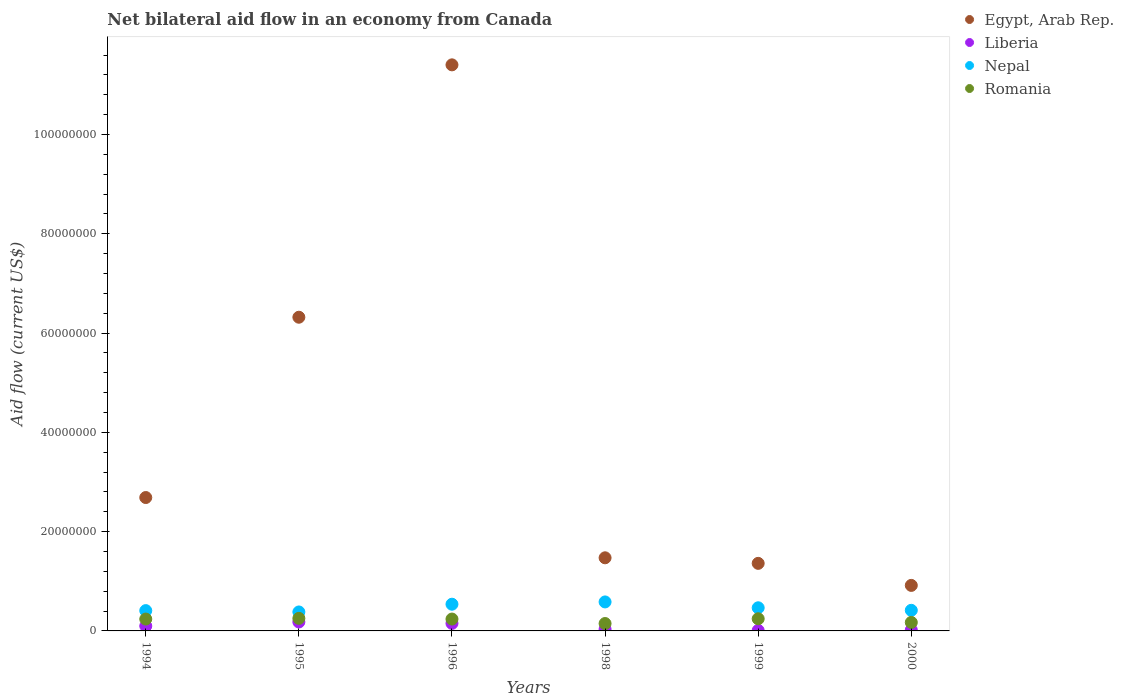How many different coloured dotlines are there?
Give a very brief answer. 4. Is the number of dotlines equal to the number of legend labels?
Your answer should be compact. Yes. What is the net bilateral aid flow in Egypt, Arab Rep. in 1999?
Your answer should be compact. 1.36e+07. Across all years, what is the maximum net bilateral aid flow in Egypt, Arab Rep.?
Your response must be concise. 1.14e+08. Across all years, what is the minimum net bilateral aid flow in Nepal?
Offer a terse response. 3.82e+06. In which year was the net bilateral aid flow in Nepal minimum?
Make the answer very short. 1995. What is the total net bilateral aid flow in Nepal in the graph?
Make the answer very short. 2.79e+07. What is the difference between the net bilateral aid flow in Egypt, Arab Rep. in 1994 and that in 1996?
Offer a very short reply. -8.72e+07. What is the difference between the net bilateral aid flow in Liberia in 1994 and the net bilateral aid flow in Romania in 1996?
Ensure brevity in your answer.  -1.40e+06. What is the average net bilateral aid flow in Liberia per year?
Provide a short and direct response. 8.23e+05. In the year 1996, what is the difference between the net bilateral aid flow in Liberia and net bilateral aid flow in Egypt, Arab Rep.?
Ensure brevity in your answer.  -1.13e+08. What is the ratio of the net bilateral aid flow in Liberia in 1994 to that in 1998?
Your answer should be very brief. 2.91. Is the difference between the net bilateral aid flow in Liberia in 1996 and 1998 greater than the difference between the net bilateral aid flow in Egypt, Arab Rep. in 1996 and 1998?
Provide a short and direct response. No. What is the difference between the highest and the lowest net bilateral aid flow in Romania?
Provide a succinct answer. 1.04e+06. Is the sum of the net bilateral aid flow in Nepal in 1996 and 1999 greater than the maximum net bilateral aid flow in Liberia across all years?
Your response must be concise. Yes. Does the net bilateral aid flow in Liberia monotonically increase over the years?
Ensure brevity in your answer.  No. How many dotlines are there?
Provide a short and direct response. 4. What is the difference between two consecutive major ticks on the Y-axis?
Keep it short and to the point. 2.00e+07. Does the graph contain grids?
Offer a very short reply. No. How many legend labels are there?
Give a very brief answer. 4. What is the title of the graph?
Provide a short and direct response. Net bilateral aid flow in an economy from Canada. What is the label or title of the Y-axis?
Give a very brief answer. Aid flow (current US$). What is the Aid flow (current US$) in Egypt, Arab Rep. in 1994?
Give a very brief answer. 2.69e+07. What is the Aid flow (current US$) of Liberia in 1994?
Give a very brief answer. 9.90e+05. What is the Aid flow (current US$) of Nepal in 1994?
Your response must be concise. 4.09e+06. What is the Aid flow (current US$) in Romania in 1994?
Ensure brevity in your answer.  2.39e+06. What is the Aid flow (current US$) in Egypt, Arab Rep. in 1995?
Give a very brief answer. 6.32e+07. What is the Aid flow (current US$) of Liberia in 1995?
Provide a short and direct response. 1.80e+06. What is the Aid flow (current US$) of Nepal in 1995?
Your answer should be compact. 3.82e+06. What is the Aid flow (current US$) of Romania in 1995?
Your response must be concise. 2.53e+06. What is the Aid flow (current US$) of Egypt, Arab Rep. in 1996?
Offer a terse response. 1.14e+08. What is the Aid flow (current US$) in Liberia in 1996?
Ensure brevity in your answer.  1.52e+06. What is the Aid flow (current US$) of Nepal in 1996?
Keep it short and to the point. 5.38e+06. What is the Aid flow (current US$) of Romania in 1996?
Offer a terse response. 2.39e+06. What is the Aid flow (current US$) of Egypt, Arab Rep. in 1998?
Make the answer very short. 1.47e+07. What is the Aid flow (current US$) of Nepal in 1998?
Provide a succinct answer. 5.84e+06. What is the Aid flow (current US$) in Romania in 1998?
Your response must be concise. 1.49e+06. What is the Aid flow (current US$) of Egypt, Arab Rep. in 1999?
Offer a terse response. 1.36e+07. What is the Aid flow (current US$) in Liberia in 1999?
Ensure brevity in your answer.  1.00e+05. What is the Aid flow (current US$) of Nepal in 1999?
Your answer should be very brief. 4.66e+06. What is the Aid flow (current US$) of Romania in 1999?
Provide a succinct answer. 2.45e+06. What is the Aid flow (current US$) in Egypt, Arab Rep. in 2000?
Make the answer very short. 9.17e+06. What is the Aid flow (current US$) in Liberia in 2000?
Your answer should be very brief. 1.90e+05. What is the Aid flow (current US$) in Nepal in 2000?
Provide a succinct answer. 4.15e+06. What is the Aid flow (current US$) of Romania in 2000?
Your answer should be compact. 1.71e+06. Across all years, what is the maximum Aid flow (current US$) of Egypt, Arab Rep.?
Keep it short and to the point. 1.14e+08. Across all years, what is the maximum Aid flow (current US$) of Liberia?
Give a very brief answer. 1.80e+06. Across all years, what is the maximum Aid flow (current US$) of Nepal?
Your answer should be very brief. 5.84e+06. Across all years, what is the maximum Aid flow (current US$) of Romania?
Make the answer very short. 2.53e+06. Across all years, what is the minimum Aid flow (current US$) in Egypt, Arab Rep.?
Give a very brief answer. 9.17e+06. Across all years, what is the minimum Aid flow (current US$) of Liberia?
Provide a succinct answer. 1.00e+05. Across all years, what is the minimum Aid flow (current US$) of Nepal?
Your answer should be very brief. 3.82e+06. Across all years, what is the minimum Aid flow (current US$) in Romania?
Offer a very short reply. 1.49e+06. What is the total Aid flow (current US$) in Egypt, Arab Rep. in the graph?
Your answer should be very brief. 2.42e+08. What is the total Aid flow (current US$) of Liberia in the graph?
Offer a very short reply. 4.94e+06. What is the total Aid flow (current US$) of Nepal in the graph?
Your answer should be very brief. 2.79e+07. What is the total Aid flow (current US$) of Romania in the graph?
Your answer should be compact. 1.30e+07. What is the difference between the Aid flow (current US$) of Egypt, Arab Rep. in 1994 and that in 1995?
Your answer should be very brief. -3.63e+07. What is the difference between the Aid flow (current US$) of Liberia in 1994 and that in 1995?
Your response must be concise. -8.10e+05. What is the difference between the Aid flow (current US$) of Egypt, Arab Rep. in 1994 and that in 1996?
Your answer should be very brief. -8.72e+07. What is the difference between the Aid flow (current US$) in Liberia in 1994 and that in 1996?
Your answer should be compact. -5.30e+05. What is the difference between the Aid flow (current US$) of Nepal in 1994 and that in 1996?
Ensure brevity in your answer.  -1.29e+06. What is the difference between the Aid flow (current US$) of Romania in 1994 and that in 1996?
Your response must be concise. 0. What is the difference between the Aid flow (current US$) of Egypt, Arab Rep. in 1994 and that in 1998?
Provide a short and direct response. 1.21e+07. What is the difference between the Aid flow (current US$) of Liberia in 1994 and that in 1998?
Offer a very short reply. 6.50e+05. What is the difference between the Aid flow (current US$) in Nepal in 1994 and that in 1998?
Your answer should be very brief. -1.75e+06. What is the difference between the Aid flow (current US$) in Romania in 1994 and that in 1998?
Your answer should be compact. 9.00e+05. What is the difference between the Aid flow (current US$) in Egypt, Arab Rep. in 1994 and that in 1999?
Your answer should be very brief. 1.33e+07. What is the difference between the Aid flow (current US$) in Liberia in 1994 and that in 1999?
Your answer should be compact. 8.90e+05. What is the difference between the Aid flow (current US$) in Nepal in 1994 and that in 1999?
Your answer should be compact. -5.70e+05. What is the difference between the Aid flow (current US$) of Romania in 1994 and that in 1999?
Your response must be concise. -6.00e+04. What is the difference between the Aid flow (current US$) in Egypt, Arab Rep. in 1994 and that in 2000?
Provide a short and direct response. 1.77e+07. What is the difference between the Aid flow (current US$) of Nepal in 1994 and that in 2000?
Give a very brief answer. -6.00e+04. What is the difference between the Aid flow (current US$) in Romania in 1994 and that in 2000?
Your answer should be very brief. 6.80e+05. What is the difference between the Aid flow (current US$) of Egypt, Arab Rep. in 1995 and that in 1996?
Your answer should be compact. -5.08e+07. What is the difference between the Aid flow (current US$) in Nepal in 1995 and that in 1996?
Offer a very short reply. -1.56e+06. What is the difference between the Aid flow (current US$) in Egypt, Arab Rep. in 1995 and that in 1998?
Make the answer very short. 4.85e+07. What is the difference between the Aid flow (current US$) in Liberia in 1995 and that in 1998?
Offer a very short reply. 1.46e+06. What is the difference between the Aid flow (current US$) of Nepal in 1995 and that in 1998?
Make the answer very short. -2.02e+06. What is the difference between the Aid flow (current US$) of Romania in 1995 and that in 1998?
Offer a very short reply. 1.04e+06. What is the difference between the Aid flow (current US$) in Egypt, Arab Rep. in 1995 and that in 1999?
Make the answer very short. 4.96e+07. What is the difference between the Aid flow (current US$) of Liberia in 1995 and that in 1999?
Your answer should be very brief. 1.70e+06. What is the difference between the Aid flow (current US$) in Nepal in 1995 and that in 1999?
Offer a very short reply. -8.40e+05. What is the difference between the Aid flow (current US$) of Egypt, Arab Rep. in 1995 and that in 2000?
Provide a short and direct response. 5.40e+07. What is the difference between the Aid flow (current US$) of Liberia in 1995 and that in 2000?
Make the answer very short. 1.61e+06. What is the difference between the Aid flow (current US$) of Nepal in 1995 and that in 2000?
Give a very brief answer. -3.30e+05. What is the difference between the Aid flow (current US$) in Romania in 1995 and that in 2000?
Your answer should be very brief. 8.20e+05. What is the difference between the Aid flow (current US$) in Egypt, Arab Rep. in 1996 and that in 1998?
Your answer should be compact. 9.93e+07. What is the difference between the Aid flow (current US$) in Liberia in 1996 and that in 1998?
Provide a short and direct response. 1.18e+06. What is the difference between the Aid flow (current US$) in Nepal in 1996 and that in 1998?
Offer a very short reply. -4.60e+05. What is the difference between the Aid flow (current US$) in Romania in 1996 and that in 1998?
Offer a very short reply. 9.00e+05. What is the difference between the Aid flow (current US$) of Egypt, Arab Rep. in 1996 and that in 1999?
Provide a short and direct response. 1.00e+08. What is the difference between the Aid flow (current US$) in Liberia in 1996 and that in 1999?
Provide a short and direct response. 1.42e+06. What is the difference between the Aid flow (current US$) in Nepal in 1996 and that in 1999?
Offer a terse response. 7.20e+05. What is the difference between the Aid flow (current US$) in Romania in 1996 and that in 1999?
Offer a very short reply. -6.00e+04. What is the difference between the Aid flow (current US$) of Egypt, Arab Rep. in 1996 and that in 2000?
Make the answer very short. 1.05e+08. What is the difference between the Aid flow (current US$) of Liberia in 1996 and that in 2000?
Provide a succinct answer. 1.33e+06. What is the difference between the Aid flow (current US$) in Nepal in 1996 and that in 2000?
Give a very brief answer. 1.23e+06. What is the difference between the Aid flow (current US$) of Romania in 1996 and that in 2000?
Your answer should be very brief. 6.80e+05. What is the difference between the Aid flow (current US$) in Egypt, Arab Rep. in 1998 and that in 1999?
Provide a succinct answer. 1.12e+06. What is the difference between the Aid flow (current US$) of Nepal in 1998 and that in 1999?
Your response must be concise. 1.18e+06. What is the difference between the Aid flow (current US$) in Romania in 1998 and that in 1999?
Your answer should be compact. -9.60e+05. What is the difference between the Aid flow (current US$) of Egypt, Arab Rep. in 1998 and that in 2000?
Your answer should be very brief. 5.56e+06. What is the difference between the Aid flow (current US$) of Liberia in 1998 and that in 2000?
Keep it short and to the point. 1.50e+05. What is the difference between the Aid flow (current US$) in Nepal in 1998 and that in 2000?
Ensure brevity in your answer.  1.69e+06. What is the difference between the Aid flow (current US$) in Romania in 1998 and that in 2000?
Ensure brevity in your answer.  -2.20e+05. What is the difference between the Aid flow (current US$) in Egypt, Arab Rep. in 1999 and that in 2000?
Give a very brief answer. 4.44e+06. What is the difference between the Aid flow (current US$) of Nepal in 1999 and that in 2000?
Keep it short and to the point. 5.10e+05. What is the difference between the Aid flow (current US$) in Romania in 1999 and that in 2000?
Offer a terse response. 7.40e+05. What is the difference between the Aid flow (current US$) of Egypt, Arab Rep. in 1994 and the Aid flow (current US$) of Liberia in 1995?
Offer a terse response. 2.51e+07. What is the difference between the Aid flow (current US$) of Egypt, Arab Rep. in 1994 and the Aid flow (current US$) of Nepal in 1995?
Give a very brief answer. 2.30e+07. What is the difference between the Aid flow (current US$) in Egypt, Arab Rep. in 1994 and the Aid flow (current US$) in Romania in 1995?
Provide a succinct answer. 2.43e+07. What is the difference between the Aid flow (current US$) of Liberia in 1994 and the Aid flow (current US$) of Nepal in 1995?
Ensure brevity in your answer.  -2.83e+06. What is the difference between the Aid flow (current US$) in Liberia in 1994 and the Aid flow (current US$) in Romania in 1995?
Offer a very short reply. -1.54e+06. What is the difference between the Aid flow (current US$) in Nepal in 1994 and the Aid flow (current US$) in Romania in 1995?
Provide a short and direct response. 1.56e+06. What is the difference between the Aid flow (current US$) of Egypt, Arab Rep. in 1994 and the Aid flow (current US$) of Liberia in 1996?
Your response must be concise. 2.54e+07. What is the difference between the Aid flow (current US$) in Egypt, Arab Rep. in 1994 and the Aid flow (current US$) in Nepal in 1996?
Offer a terse response. 2.15e+07. What is the difference between the Aid flow (current US$) of Egypt, Arab Rep. in 1994 and the Aid flow (current US$) of Romania in 1996?
Offer a terse response. 2.45e+07. What is the difference between the Aid flow (current US$) of Liberia in 1994 and the Aid flow (current US$) of Nepal in 1996?
Your response must be concise. -4.39e+06. What is the difference between the Aid flow (current US$) of Liberia in 1994 and the Aid flow (current US$) of Romania in 1996?
Keep it short and to the point. -1.40e+06. What is the difference between the Aid flow (current US$) of Nepal in 1994 and the Aid flow (current US$) of Romania in 1996?
Provide a succinct answer. 1.70e+06. What is the difference between the Aid flow (current US$) in Egypt, Arab Rep. in 1994 and the Aid flow (current US$) in Liberia in 1998?
Keep it short and to the point. 2.65e+07. What is the difference between the Aid flow (current US$) in Egypt, Arab Rep. in 1994 and the Aid flow (current US$) in Nepal in 1998?
Ensure brevity in your answer.  2.10e+07. What is the difference between the Aid flow (current US$) of Egypt, Arab Rep. in 1994 and the Aid flow (current US$) of Romania in 1998?
Provide a succinct answer. 2.54e+07. What is the difference between the Aid flow (current US$) in Liberia in 1994 and the Aid flow (current US$) in Nepal in 1998?
Your response must be concise. -4.85e+06. What is the difference between the Aid flow (current US$) of Liberia in 1994 and the Aid flow (current US$) of Romania in 1998?
Offer a very short reply. -5.00e+05. What is the difference between the Aid flow (current US$) of Nepal in 1994 and the Aid flow (current US$) of Romania in 1998?
Ensure brevity in your answer.  2.60e+06. What is the difference between the Aid flow (current US$) of Egypt, Arab Rep. in 1994 and the Aid flow (current US$) of Liberia in 1999?
Provide a short and direct response. 2.68e+07. What is the difference between the Aid flow (current US$) of Egypt, Arab Rep. in 1994 and the Aid flow (current US$) of Nepal in 1999?
Your answer should be compact. 2.22e+07. What is the difference between the Aid flow (current US$) in Egypt, Arab Rep. in 1994 and the Aid flow (current US$) in Romania in 1999?
Provide a short and direct response. 2.44e+07. What is the difference between the Aid flow (current US$) in Liberia in 1994 and the Aid flow (current US$) in Nepal in 1999?
Ensure brevity in your answer.  -3.67e+06. What is the difference between the Aid flow (current US$) in Liberia in 1994 and the Aid flow (current US$) in Romania in 1999?
Your answer should be compact. -1.46e+06. What is the difference between the Aid flow (current US$) in Nepal in 1994 and the Aid flow (current US$) in Romania in 1999?
Provide a succinct answer. 1.64e+06. What is the difference between the Aid flow (current US$) in Egypt, Arab Rep. in 1994 and the Aid flow (current US$) in Liberia in 2000?
Ensure brevity in your answer.  2.67e+07. What is the difference between the Aid flow (current US$) of Egypt, Arab Rep. in 1994 and the Aid flow (current US$) of Nepal in 2000?
Your answer should be compact. 2.27e+07. What is the difference between the Aid flow (current US$) in Egypt, Arab Rep. in 1994 and the Aid flow (current US$) in Romania in 2000?
Give a very brief answer. 2.52e+07. What is the difference between the Aid flow (current US$) of Liberia in 1994 and the Aid flow (current US$) of Nepal in 2000?
Offer a very short reply. -3.16e+06. What is the difference between the Aid flow (current US$) of Liberia in 1994 and the Aid flow (current US$) of Romania in 2000?
Your response must be concise. -7.20e+05. What is the difference between the Aid flow (current US$) in Nepal in 1994 and the Aid flow (current US$) in Romania in 2000?
Give a very brief answer. 2.38e+06. What is the difference between the Aid flow (current US$) in Egypt, Arab Rep. in 1995 and the Aid flow (current US$) in Liberia in 1996?
Your response must be concise. 6.17e+07. What is the difference between the Aid flow (current US$) in Egypt, Arab Rep. in 1995 and the Aid flow (current US$) in Nepal in 1996?
Your answer should be compact. 5.78e+07. What is the difference between the Aid flow (current US$) of Egypt, Arab Rep. in 1995 and the Aid flow (current US$) of Romania in 1996?
Give a very brief answer. 6.08e+07. What is the difference between the Aid flow (current US$) in Liberia in 1995 and the Aid flow (current US$) in Nepal in 1996?
Your response must be concise. -3.58e+06. What is the difference between the Aid flow (current US$) of Liberia in 1995 and the Aid flow (current US$) of Romania in 1996?
Offer a very short reply. -5.90e+05. What is the difference between the Aid flow (current US$) of Nepal in 1995 and the Aid flow (current US$) of Romania in 1996?
Offer a terse response. 1.43e+06. What is the difference between the Aid flow (current US$) in Egypt, Arab Rep. in 1995 and the Aid flow (current US$) in Liberia in 1998?
Your answer should be very brief. 6.28e+07. What is the difference between the Aid flow (current US$) in Egypt, Arab Rep. in 1995 and the Aid flow (current US$) in Nepal in 1998?
Your answer should be compact. 5.74e+07. What is the difference between the Aid flow (current US$) in Egypt, Arab Rep. in 1995 and the Aid flow (current US$) in Romania in 1998?
Provide a short and direct response. 6.17e+07. What is the difference between the Aid flow (current US$) in Liberia in 1995 and the Aid flow (current US$) in Nepal in 1998?
Offer a very short reply. -4.04e+06. What is the difference between the Aid flow (current US$) of Nepal in 1995 and the Aid flow (current US$) of Romania in 1998?
Ensure brevity in your answer.  2.33e+06. What is the difference between the Aid flow (current US$) of Egypt, Arab Rep. in 1995 and the Aid flow (current US$) of Liberia in 1999?
Give a very brief answer. 6.31e+07. What is the difference between the Aid flow (current US$) in Egypt, Arab Rep. in 1995 and the Aid flow (current US$) in Nepal in 1999?
Your answer should be compact. 5.85e+07. What is the difference between the Aid flow (current US$) in Egypt, Arab Rep. in 1995 and the Aid flow (current US$) in Romania in 1999?
Your response must be concise. 6.07e+07. What is the difference between the Aid flow (current US$) of Liberia in 1995 and the Aid flow (current US$) of Nepal in 1999?
Offer a terse response. -2.86e+06. What is the difference between the Aid flow (current US$) in Liberia in 1995 and the Aid flow (current US$) in Romania in 1999?
Offer a terse response. -6.50e+05. What is the difference between the Aid flow (current US$) of Nepal in 1995 and the Aid flow (current US$) of Romania in 1999?
Ensure brevity in your answer.  1.37e+06. What is the difference between the Aid flow (current US$) of Egypt, Arab Rep. in 1995 and the Aid flow (current US$) of Liberia in 2000?
Your response must be concise. 6.30e+07. What is the difference between the Aid flow (current US$) in Egypt, Arab Rep. in 1995 and the Aid flow (current US$) in Nepal in 2000?
Offer a very short reply. 5.90e+07. What is the difference between the Aid flow (current US$) in Egypt, Arab Rep. in 1995 and the Aid flow (current US$) in Romania in 2000?
Provide a short and direct response. 6.15e+07. What is the difference between the Aid flow (current US$) of Liberia in 1995 and the Aid flow (current US$) of Nepal in 2000?
Your answer should be compact. -2.35e+06. What is the difference between the Aid flow (current US$) in Liberia in 1995 and the Aid flow (current US$) in Romania in 2000?
Provide a succinct answer. 9.00e+04. What is the difference between the Aid flow (current US$) of Nepal in 1995 and the Aid flow (current US$) of Romania in 2000?
Offer a terse response. 2.11e+06. What is the difference between the Aid flow (current US$) in Egypt, Arab Rep. in 1996 and the Aid flow (current US$) in Liberia in 1998?
Keep it short and to the point. 1.14e+08. What is the difference between the Aid flow (current US$) of Egypt, Arab Rep. in 1996 and the Aid flow (current US$) of Nepal in 1998?
Keep it short and to the point. 1.08e+08. What is the difference between the Aid flow (current US$) of Egypt, Arab Rep. in 1996 and the Aid flow (current US$) of Romania in 1998?
Offer a very short reply. 1.13e+08. What is the difference between the Aid flow (current US$) of Liberia in 1996 and the Aid flow (current US$) of Nepal in 1998?
Provide a short and direct response. -4.32e+06. What is the difference between the Aid flow (current US$) in Nepal in 1996 and the Aid flow (current US$) in Romania in 1998?
Provide a short and direct response. 3.89e+06. What is the difference between the Aid flow (current US$) in Egypt, Arab Rep. in 1996 and the Aid flow (current US$) in Liberia in 1999?
Keep it short and to the point. 1.14e+08. What is the difference between the Aid flow (current US$) in Egypt, Arab Rep. in 1996 and the Aid flow (current US$) in Nepal in 1999?
Give a very brief answer. 1.09e+08. What is the difference between the Aid flow (current US$) of Egypt, Arab Rep. in 1996 and the Aid flow (current US$) of Romania in 1999?
Your response must be concise. 1.12e+08. What is the difference between the Aid flow (current US$) of Liberia in 1996 and the Aid flow (current US$) of Nepal in 1999?
Provide a succinct answer. -3.14e+06. What is the difference between the Aid flow (current US$) of Liberia in 1996 and the Aid flow (current US$) of Romania in 1999?
Provide a short and direct response. -9.30e+05. What is the difference between the Aid flow (current US$) in Nepal in 1996 and the Aid flow (current US$) in Romania in 1999?
Your response must be concise. 2.93e+06. What is the difference between the Aid flow (current US$) in Egypt, Arab Rep. in 1996 and the Aid flow (current US$) in Liberia in 2000?
Offer a very short reply. 1.14e+08. What is the difference between the Aid flow (current US$) of Egypt, Arab Rep. in 1996 and the Aid flow (current US$) of Nepal in 2000?
Your answer should be very brief. 1.10e+08. What is the difference between the Aid flow (current US$) of Egypt, Arab Rep. in 1996 and the Aid flow (current US$) of Romania in 2000?
Provide a short and direct response. 1.12e+08. What is the difference between the Aid flow (current US$) in Liberia in 1996 and the Aid flow (current US$) in Nepal in 2000?
Provide a succinct answer. -2.63e+06. What is the difference between the Aid flow (current US$) of Liberia in 1996 and the Aid flow (current US$) of Romania in 2000?
Offer a terse response. -1.90e+05. What is the difference between the Aid flow (current US$) in Nepal in 1996 and the Aid flow (current US$) in Romania in 2000?
Make the answer very short. 3.67e+06. What is the difference between the Aid flow (current US$) of Egypt, Arab Rep. in 1998 and the Aid flow (current US$) of Liberia in 1999?
Give a very brief answer. 1.46e+07. What is the difference between the Aid flow (current US$) in Egypt, Arab Rep. in 1998 and the Aid flow (current US$) in Nepal in 1999?
Your answer should be compact. 1.01e+07. What is the difference between the Aid flow (current US$) in Egypt, Arab Rep. in 1998 and the Aid flow (current US$) in Romania in 1999?
Provide a short and direct response. 1.23e+07. What is the difference between the Aid flow (current US$) in Liberia in 1998 and the Aid flow (current US$) in Nepal in 1999?
Make the answer very short. -4.32e+06. What is the difference between the Aid flow (current US$) of Liberia in 1998 and the Aid flow (current US$) of Romania in 1999?
Your response must be concise. -2.11e+06. What is the difference between the Aid flow (current US$) of Nepal in 1998 and the Aid flow (current US$) of Romania in 1999?
Offer a very short reply. 3.39e+06. What is the difference between the Aid flow (current US$) in Egypt, Arab Rep. in 1998 and the Aid flow (current US$) in Liberia in 2000?
Your response must be concise. 1.45e+07. What is the difference between the Aid flow (current US$) in Egypt, Arab Rep. in 1998 and the Aid flow (current US$) in Nepal in 2000?
Make the answer very short. 1.06e+07. What is the difference between the Aid flow (current US$) in Egypt, Arab Rep. in 1998 and the Aid flow (current US$) in Romania in 2000?
Offer a terse response. 1.30e+07. What is the difference between the Aid flow (current US$) in Liberia in 1998 and the Aid flow (current US$) in Nepal in 2000?
Offer a very short reply. -3.81e+06. What is the difference between the Aid flow (current US$) of Liberia in 1998 and the Aid flow (current US$) of Romania in 2000?
Ensure brevity in your answer.  -1.37e+06. What is the difference between the Aid flow (current US$) in Nepal in 1998 and the Aid flow (current US$) in Romania in 2000?
Provide a short and direct response. 4.13e+06. What is the difference between the Aid flow (current US$) in Egypt, Arab Rep. in 1999 and the Aid flow (current US$) in Liberia in 2000?
Offer a terse response. 1.34e+07. What is the difference between the Aid flow (current US$) in Egypt, Arab Rep. in 1999 and the Aid flow (current US$) in Nepal in 2000?
Your answer should be compact. 9.46e+06. What is the difference between the Aid flow (current US$) in Egypt, Arab Rep. in 1999 and the Aid flow (current US$) in Romania in 2000?
Your response must be concise. 1.19e+07. What is the difference between the Aid flow (current US$) in Liberia in 1999 and the Aid flow (current US$) in Nepal in 2000?
Your answer should be compact. -4.05e+06. What is the difference between the Aid flow (current US$) in Liberia in 1999 and the Aid flow (current US$) in Romania in 2000?
Provide a succinct answer. -1.61e+06. What is the difference between the Aid flow (current US$) of Nepal in 1999 and the Aid flow (current US$) of Romania in 2000?
Provide a succinct answer. 2.95e+06. What is the average Aid flow (current US$) in Egypt, Arab Rep. per year?
Your response must be concise. 4.03e+07. What is the average Aid flow (current US$) in Liberia per year?
Give a very brief answer. 8.23e+05. What is the average Aid flow (current US$) of Nepal per year?
Provide a succinct answer. 4.66e+06. What is the average Aid flow (current US$) in Romania per year?
Offer a very short reply. 2.16e+06. In the year 1994, what is the difference between the Aid flow (current US$) in Egypt, Arab Rep. and Aid flow (current US$) in Liberia?
Provide a succinct answer. 2.59e+07. In the year 1994, what is the difference between the Aid flow (current US$) of Egypt, Arab Rep. and Aid flow (current US$) of Nepal?
Your answer should be very brief. 2.28e+07. In the year 1994, what is the difference between the Aid flow (current US$) in Egypt, Arab Rep. and Aid flow (current US$) in Romania?
Your answer should be very brief. 2.45e+07. In the year 1994, what is the difference between the Aid flow (current US$) of Liberia and Aid flow (current US$) of Nepal?
Offer a terse response. -3.10e+06. In the year 1994, what is the difference between the Aid flow (current US$) of Liberia and Aid flow (current US$) of Romania?
Your response must be concise. -1.40e+06. In the year 1994, what is the difference between the Aid flow (current US$) in Nepal and Aid flow (current US$) in Romania?
Your response must be concise. 1.70e+06. In the year 1995, what is the difference between the Aid flow (current US$) of Egypt, Arab Rep. and Aid flow (current US$) of Liberia?
Your answer should be very brief. 6.14e+07. In the year 1995, what is the difference between the Aid flow (current US$) in Egypt, Arab Rep. and Aid flow (current US$) in Nepal?
Your response must be concise. 5.94e+07. In the year 1995, what is the difference between the Aid flow (current US$) in Egypt, Arab Rep. and Aid flow (current US$) in Romania?
Provide a short and direct response. 6.07e+07. In the year 1995, what is the difference between the Aid flow (current US$) of Liberia and Aid flow (current US$) of Nepal?
Make the answer very short. -2.02e+06. In the year 1995, what is the difference between the Aid flow (current US$) of Liberia and Aid flow (current US$) of Romania?
Your answer should be compact. -7.30e+05. In the year 1995, what is the difference between the Aid flow (current US$) in Nepal and Aid flow (current US$) in Romania?
Offer a terse response. 1.29e+06. In the year 1996, what is the difference between the Aid flow (current US$) of Egypt, Arab Rep. and Aid flow (current US$) of Liberia?
Keep it short and to the point. 1.13e+08. In the year 1996, what is the difference between the Aid flow (current US$) of Egypt, Arab Rep. and Aid flow (current US$) of Nepal?
Your answer should be very brief. 1.09e+08. In the year 1996, what is the difference between the Aid flow (current US$) in Egypt, Arab Rep. and Aid flow (current US$) in Romania?
Provide a succinct answer. 1.12e+08. In the year 1996, what is the difference between the Aid flow (current US$) of Liberia and Aid flow (current US$) of Nepal?
Keep it short and to the point. -3.86e+06. In the year 1996, what is the difference between the Aid flow (current US$) in Liberia and Aid flow (current US$) in Romania?
Provide a succinct answer. -8.70e+05. In the year 1996, what is the difference between the Aid flow (current US$) in Nepal and Aid flow (current US$) in Romania?
Give a very brief answer. 2.99e+06. In the year 1998, what is the difference between the Aid flow (current US$) of Egypt, Arab Rep. and Aid flow (current US$) of Liberia?
Offer a terse response. 1.44e+07. In the year 1998, what is the difference between the Aid flow (current US$) of Egypt, Arab Rep. and Aid flow (current US$) of Nepal?
Your answer should be compact. 8.89e+06. In the year 1998, what is the difference between the Aid flow (current US$) in Egypt, Arab Rep. and Aid flow (current US$) in Romania?
Make the answer very short. 1.32e+07. In the year 1998, what is the difference between the Aid flow (current US$) in Liberia and Aid flow (current US$) in Nepal?
Provide a succinct answer. -5.50e+06. In the year 1998, what is the difference between the Aid flow (current US$) in Liberia and Aid flow (current US$) in Romania?
Keep it short and to the point. -1.15e+06. In the year 1998, what is the difference between the Aid flow (current US$) of Nepal and Aid flow (current US$) of Romania?
Give a very brief answer. 4.35e+06. In the year 1999, what is the difference between the Aid flow (current US$) of Egypt, Arab Rep. and Aid flow (current US$) of Liberia?
Offer a terse response. 1.35e+07. In the year 1999, what is the difference between the Aid flow (current US$) in Egypt, Arab Rep. and Aid flow (current US$) in Nepal?
Provide a short and direct response. 8.95e+06. In the year 1999, what is the difference between the Aid flow (current US$) of Egypt, Arab Rep. and Aid flow (current US$) of Romania?
Give a very brief answer. 1.12e+07. In the year 1999, what is the difference between the Aid flow (current US$) in Liberia and Aid flow (current US$) in Nepal?
Ensure brevity in your answer.  -4.56e+06. In the year 1999, what is the difference between the Aid flow (current US$) in Liberia and Aid flow (current US$) in Romania?
Your answer should be compact. -2.35e+06. In the year 1999, what is the difference between the Aid flow (current US$) of Nepal and Aid flow (current US$) of Romania?
Give a very brief answer. 2.21e+06. In the year 2000, what is the difference between the Aid flow (current US$) of Egypt, Arab Rep. and Aid flow (current US$) of Liberia?
Provide a succinct answer. 8.98e+06. In the year 2000, what is the difference between the Aid flow (current US$) in Egypt, Arab Rep. and Aid flow (current US$) in Nepal?
Provide a succinct answer. 5.02e+06. In the year 2000, what is the difference between the Aid flow (current US$) in Egypt, Arab Rep. and Aid flow (current US$) in Romania?
Offer a terse response. 7.46e+06. In the year 2000, what is the difference between the Aid flow (current US$) in Liberia and Aid flow (current US$) in Nepal?
Provide a succinct answer. -3.96e+06. In the year 2000, what is the difference between the Aid flow (current US$) of Liberia and Aid flow (current US$) of Romania?
Give a very brief answer. -1.52e+06. In the year 2000, what is the difference between the Aid flow (current US$) in Nepal and Aid flow (current US$) in Romania?
Offer a terse response. 2.44e+06. What is the ratio of the Aid flow (current US$) of Egypt, Arab Rep. in 1994 to that in 1995?
Your answer should be very brief. 0.43. What is the ratio of the Aid flow (current US$) in Liberia in 1994 to that in 1995?
Your answer should be compact. 0.55. What is the ratio of the Aid flow (current US$) of Nepal in 1994 to that in 1995?
Your answer should be compact. 1.07. What is the ratio of the Aid flow (current US$) of Romania in 1994 to that in 1995?
Offer a terse response. 0.94. What is the ratio of the Aid flow (current US$) of Egypt, Arab Rep. in 1994 to that in 1996?
Make the answer very short. 0.24. What is the ratio of the Aid flow (current US$) of Liberia in 1994 to that in 1996?
Ensure brevity in your answer.  0.65. What is the ratio of the Aid flow (current US$) of Nepal in 1994 to that in 1996?
Offer a very short reply. 0.76. What is the ratio of the Aid flow (current US$) of Egypt, Arab Rep. in 1994 to that in 1998?
Provide a short and direct response. 1.82. What is the ratio of the Aid flow (current US$) in Liberia in 1994 to that in 1998?
Provide a short and direct response. 2.91. What is the ratio of the Aid flow (current US$) of Nepal in 1994 to that in 1998?
Offer a terse response. 0.7. What is the ratio of the Aid flow (current US$) in Romania in 1994 to that in 1998?
Give a very brief answer. 1.6. What is the ratio of the Aid flow (current US$) of Egypt, Arab Rep. in 1994 to that in 1999?
Ensure brevity in your answer.  1.97. What is the ratio of the Aid flow (current US$) of Nepal in 1994 to that in 1999?
Offer a very short reply. 0.88. What is the ratio of the Aid flow (current US$) in Romania in 1994 to that in 1999?
Your response must be concise. 0.98. What is the ratio of the Aid flow (current US$) in Egypt, Arab Rep. in 1994 to that in 2000?
Keep it short and to the point. 2.93. What is the ratio of the Aid flow (current US$) in Liberia in 1994 to that in 2000?
Give a very brief answer. 5.21. What is the ratio of the Aid flow (current US$) of Nepal in 1994 to that in 2000?
Keep it short and to the point. 0.99. What is the ratio of the Aid flow (current US$) in Romania in 1994 to that in 2000?
Your answer should be very brief. 1.4. What is the ratio of the Aid flow (current US$) in Egypt, Arab Rep. in 1995 to that in 1996?
Keep it short and to the point. 0.55. What is the ratio of the Aid flow (current US$) of Liberia in 1995 to that in 1996?
Offer a terse response. 1.18. What is the ratio of the Aid flow (current US$) in Nepal in 1995 to that in 1996?
Your answer should be compact. 0.71. What is the ratio of the Aid flow (current US$) of Romania in 1995 to that in 1996?
Give a very brief answer. 1.06. What is the ratio of the Aid flow (current US$) of Egypt, Arab Rep. in 1995 to that in 1998?
Keep it short and to the point. 4.29. What is the ratio of the Aid flow (current US$) of Liberia in 1995 to that in 1998?
Provide a short and direct response. 5.29. What is the ratio of the Aid flow (current US$) in Nepal in 1995 to that in 1998?
Give a very brief answer. 0.65. What is the ratio of the Aid flow (current US$) in Romania in 1995 to that in 1998?
Your answer should be compact. 1.7. What is the ratio of the Aid flow (current US$) in Egypt, Arab Rep. in 1995 to that in 1999?
Make the answer very short. 4.64. What is the ratio of the Aid flow (current US$) of Liberia in 1995 to that in 1999?
Your response must be concise. 18. What is the ratio of the Aid flow (current US$) in Nepal in 1995 to that in 1999?
Your answer should be very brief. 0.82. What is the ratio of the Aid flow (current US$) in Romania in 1995 to that in 1999?
Your response must be concise. 1.03. What is the ratio of the Aid flow (current US$) in Egypt, Arab Rep. in 1995 to that in 2000?
Provide a succinct answer. 6.89. What is the ratio of the Aid flow (current US$) of Liberia in 1995 to that in 2000?
Your response must be concise. 9.47. What is the ratio of the Aid flow (current US$) in Nepal in 1995 to that in 2000?
Your response must be concise. 0.92. What is the ratio of the Aid flow (current US$) of Romania in 1995 to that in 2000?
Provide a short and direct response. 1.48. What is the ratio of the Aid flow (current US$) in Egypt, Arab Rep. in 1996 to that in 1998?
Your answer should be very brief. 7.74. What is the ratio of the Aid flow (current US$) in Liberia in 1996 to that in 1998?
Ensure brevity in your answer.  4.47. What is the ratio of the Aid flow (current US$) of Nepal in 1996 to that in 1998?
Offer a very short reply. 0.92. What is the ratio of the Aid flow (current US$) of Romania in 1996 to that in 1998?
Your answer should be very brief. 1.6. What is the ratio of the Aid flow (current US$) in Egypt, Arab Rep. in 1996 to that in 1999?
Your answer should be very brief. 8.38. What is the ratio of the Aid flow (current US$) in Liberia in 1996 to that in 1999?
Ensure brevity in your answer.  15.2. What is the ratio of the Aid flow (current US$) of Nepal in 1996 to that in 1999?
Provide a succinct answer. 1.15. What is the ratio of the Aid flow (current US$) of Romania in 1996 to that in 1999?
Keep it short and to the point. 0.98. What is the ratio of the Aid flow (current US$) of Egypt, Arab Rep. in 1996 to that in 2000?
Your answer should be very brief. 12.44. What is the ratio of the Aid flow (current US$) in Liberia in 1996 to that in 2000?
Your answer should be compact. 8. What is the ratio of the Aid flow (current US$) of Nepal in 1996 to that in 2000?
Provide a succinct answer. 1.3. What is the ratio of the Aid flow (current US$) in Romania in 1996 to that in 2000?
Your response must be concise. 1.4. What is the ratio of the Aid flow (current US$) in Egypt, Arab Rep. in 1998 to that in 1999?
Offer a very short reply. 1.08. What is the ratio of the Aid flow (current US$) of Nepal in 1998 to that in 1999?
Provide a succinct answer. 1.25. What is the ratio of the Aid flow (current US$) of Romania in 1998 to that in 1999?
Your answer should be compact. 0.61. What is the ratio of the Aid flow (current US$) in Egypt, Arab Rep. in 1998 to that in 2000?
Your answer should be very brief. 1.61. What is the ratio of the Aid flow (current US$) in Liberia in 1998 to that in 2000?
Your response must be concise. 1.79. What is the ratio of the Aid flow (current US$) in Nepal in 1998 to that in 2000?
Make the answer very short. 1.41. What is the ratio of the Aid flow (current US$) in Romania in 1998 to that in 2000?
Keep it short and to the point. 0.87. What is the ratio of the Aid flow (current US$) in Egypt, Arab Rep. in 1999 to that in 2000?
Your response must be concise. 1.48. What is the ratio of the Aid flow (current US$) in Liberia in 1999 to that in 2000?
Offer a terse response. 0.53. What is the ratio of the Aid flow (current US$) in Nepal in 1999 to that in 2000?
Your answer should be compact. 1.12. What is the ratio of the Aid flow (current US$) of Romania in 1999 to that in 2000?
Give a very brief answer. 1.43. What is the difference between the highest and the second highest Aid flow (current US$) in Egypt, Arab Rep.?
Keep it short and to the point. 5.08e+07. What is the difference between the highest and the second highest Aid flow (current US$) of Romania?
Your response must be concise. 8.00e+04. What is the difference between the highest and the lowest Aid flow (current US$) of Egypt, Arab Rep.?
Ensure brevity in your answer.  1.05e+08. What is the difference between the highest and the lowest Aid flow (current US$) in Liberia?
Give a very brief answer. 1.70e+06. What is the difference between the highest and the lowest Aid flow (current US$) in Nepal?
Your answer should be very brief. 2.02e+06. What is the difference between the highest and the lowest Aid flow (current US$) in Romania?
Offer a very short reply. 1.04e+06. 